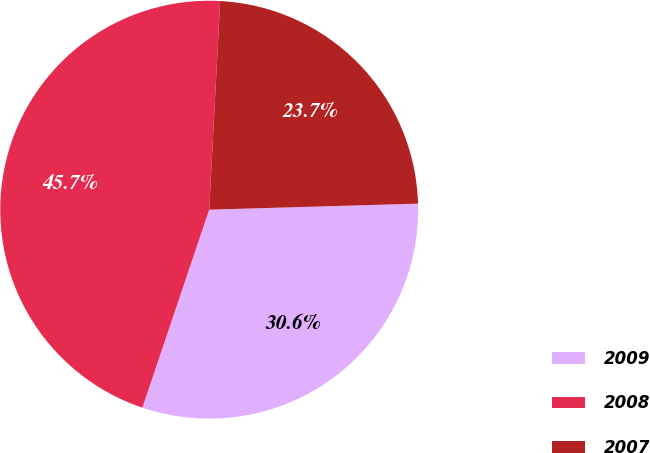<chart> <loc_0><loc_0><loc_500><loc_500><pie_chart><fcel>2009<fcel>2008<fcel>2007<nl><fcel>30.64%<fcel>45.66%<fcel>23.7%<nl></chart> 